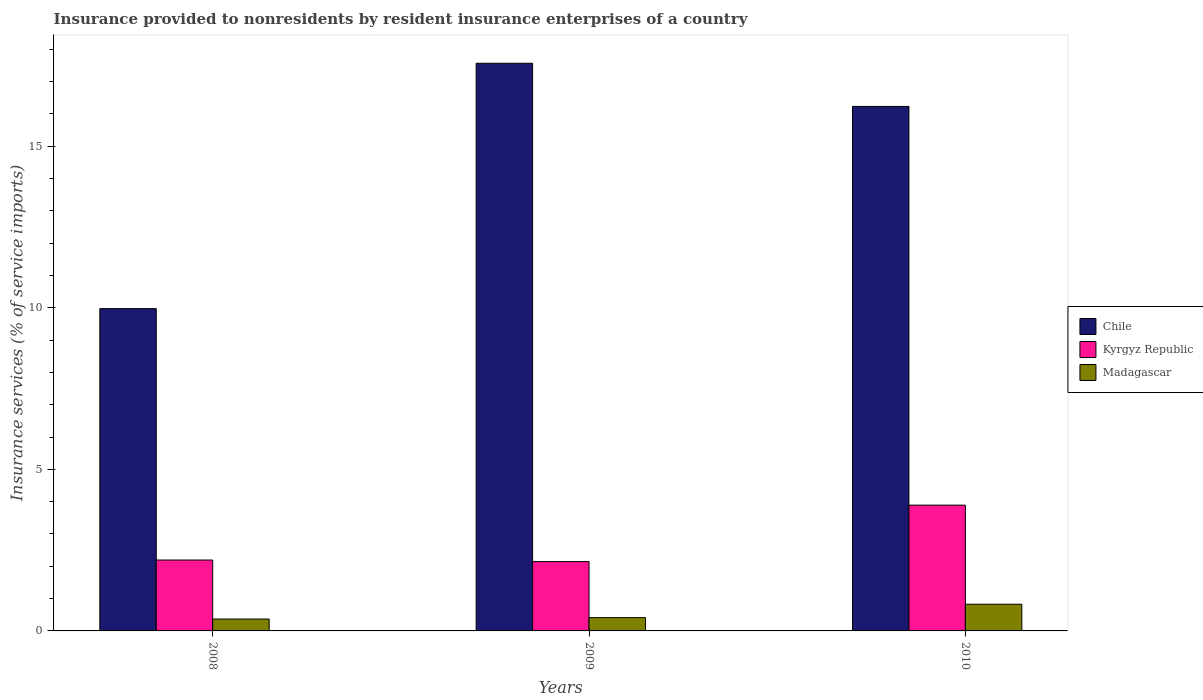How many groups of bars are there?
Provide a short and direct response. 3. Are the number of bars on each tick of the X-axis equal?
Provide a succinct answer. Yes. How many bars are there on the 3rd tick from the right?
Your response must be concise. 3. What is the insurance provided to nonresidents in Madagascar in 2010?
Ensure brevity in your answer.  0.83. Across all years, what is the maximum insurance provided to nonresidents in Kyrgyz Republic?
Your answer should be compact. 3.89. Across all years, what is the minimum insurance provided to nonresidents in Kyrgyz Republic?
Your answer should be very brief. 2.15. In which year was the insurance provided to nonresidents in Kyrgyz Republic minimum?
Offer a terse response. 2009. What is the total insurance provided to nonresidents in Chile in the graph?
Give a very brief answer. 43.78. What is the difference between the insurance provided to nonresidents in Kyrgyz Republic in 2009 and that in 2010?
Make the answer very short. -1.75. What is the difference between the insurance provided to nonresidents in Madagascar in 2008 and the insurance provided to nonresidents in Chile in 2010?
Keep it short and to the point. -15.87. What is the average insurance provided to nonresidents in Chile per year?
Keep it short and to the point. 14.59. In the year 2010, what is the difference between the insurance provided to nonresidents in Kyrgyz Republic and insurance provided to nonresidents in Madagascar?
Offer a very short reply. 3.07. In how many years, is the insurance provided to nonresidents in Madagascar greater than 16 %?
Offer a very short reply. 0. What is the ratio of the insurance provided to nonresidents in Madagascar in 2008 to that in 2009?
Your answer should be compact. 0.89. Is the difference between the insurance provided to nonresidents in Kyrgyz Republic in 2008 and 2010 greater than the difference between the insurance provided to nonresidents in Madagascar in 2008 and 2010?
Offer a terse response. No. What is the difference between the highest and the second highest insurance provided to nonresidents in Kyrgyz Republic?
Offer a terse response. 1.7. What is the difference between the highest and the lowest insurance provided to nonresidents in Madagascar?
Provide a short and direct response. 0.46. In how many years, is the insurance provided to nonresidents in Chile greater than the average insurance provided to nonresidents in Chile taken over all years?
Give a very brief answer. 2. Is the sum of the insurance provided to nonresidents in Kyrgyz Republic in 2009 and 2010 greater than the maximum insurance provided to nonresidents in Chile across all years?
Offer a terse response. No. What does the 2nd bar from the left in 2010 represents?
Give a very brief answer. Kyrgyz Republic. What does the 3rd bar from the right in 2008 represents?
Keep it short and to the point. Chile. Is it the case that in every year, the sum of the insurance provided to nonresidents in Kyrgyz Republic and insurance provided to nonresidents in Chile is greater than the insurance provided to nonresidents in Madagascar?
Provide a succinct answer. Yes. Are all the bars in the graph horizontal?
Provide a short and direct response. No. How many years are there in the graph?
Provide a succinct answer. 3. What is the difference between two consecutive major ticks on the Y-axis?
Provide a succinct answer. 5. Where does the legend appear in the graph?
Your response must be concise. Center right. What is the title of the graph?
Keep it short and to the point. Insurance provided to nonresidents by resident insurance enterprises of a country. What is the label or title of the Y-axis?
Your answer should be very brief. Insurance services (% of service imports). What is the Insurance services (% of service imports) of Chile in 2008?
Keep it short and to the point. 9.98. What is the Insurance services (% of service imports) of Kyrgyz Republic in 2008?
Ensure brevity in your answer.  2.19. What is the Insurance services (% of service imports) in Madagascar in 2008?
Make the answer very short. 0.37. What is the Insurance services (% of service imports) of Chile in 2009?
Keep it short and to the point. 17.57. What is the Insurance services (% of service imports) of Kyrgyz Republic in 2009?
Offer a very short reply. 2.15. What is the Insurance services (% of service imports) of Madagascar in 2009?
Keep it short and to the point. 0.41. What is the Insurance services (% of service imports) of Chile in 2010?
Provide a succinct answer. 16.23. What is the Insurance services (% of service imports) in Kyrgyz Republic in 2010?
Make the answer very short. 3.89. What is the Insurance services (% of service imports) of Madagascar in 2010?
Make the answer very short. 0.83. Across all years, what is the maximum Insurance services (% of service imports) of Chile?
Your answer should be compact. 17.57. Across all years, what is the maximum Insurance services (% of service imports) of Kyrgyz Republic?
Offer a very short reply. 3.89. Across all years, what is the maximum Insurance services (% of service imports) of Madagascar?
Your response must be concise. 0.83. Across all years, what is the minimum Insurance services (% of service imports) of Chile?
Ensure brevity in your answer.  9.98. Across all years, what is the minimum Insurance services (% of service imports) in Kyrgyz Republic?
Provide a short and direct response. 2.15. Across all years, what is the minimum Insurance services (% of service imports) in Madagascar?
Give a very brief answer. 0.37. What is the total Insurance services (% of service imports) of Chile in the graph?
Offer a very short reply. 43.78. What is the total Insurance services (% of service imports) in Kyrgyz Republic in the graph?
Give a very brief answer. 8.23. What is the total Insurance services (% of service imports) in Madagascar in the graph?
Your answer should be compact. 1.61. What is the difference between the Insurance services (% of service imports) in Chile in 2008 and that in 2009?
Your response must be concise. -7.59. What is the difference between the Insurance services (% of service imports) in Kyrgyz Republic in 2008 and that in 2009?
Your answer should be very brief. 0.05. What is the difference between the Insurance services (% of service imports) of Madagascar in 2008 and that in 2009?
Keep it short and to the point. -0.04. What is the difference between the Insurance services (% of service imports) of Chile in 2008 and that in 2010?
Your answer should be compact. -6.26. What is the difference between the Insurance services (% of service imports) of Kyrgyz Republic in 2008 and that in 2010?
Offer a very short reply. -1.7. What is the difference between the Insurance services (% of service imports) of Madagascar in 2008 and that in 2010?
Your response must be concise. -0.46. What is the difference between the Insurance services (% of service imports) of Chile in 2009 and that in 2010?
Keep it short and to the point. 1.34. What is the difference between the Insurance services (% of service imports) of Kyrgyz Republic in 2009 and that in 2010?
Your response must be concise. -1.75. What is the difference between the Insurance services (% of service imports) of Madagascar in 2009 and that in 2010?
Make the answer very short. -0.41. What is the difference between the Insurance services (% of service imports) of Chile in 2008 and the Insurance services (% of service imports) of Kyrgyz Republic in 2009?
Provide a succinct answer. 7.83. What is the difference between the Insurance services (% of service imports) of Chile in 2008 and the Insurance services (% of service imports) of Madagascar in 2009?
Your response must be concise. 9.56. What is the difference between the Insurance services (% of service imports) of Kyrgyz Republic in 2008 and the Insurance services (% of service imports) of Madagascar in 2009?
Provide a succinct answer. 1.78. What is the difference between the Insurance services (% of service imports) in Chile in 2008 and the Insurance services (% of service imports) in Kyrgyz Republic in 2010?
Your answer should be compact. 6.08. What is the difference between the Insurance services (% of service imports) in Chile in 2008 and the Insurance services (% of service imports) in Madagascar in 2010?
Keep it short and to the point. 9.15. What is the difference between the Insurance services (% of service imports) in Kyrgyz Republic in 2008 and the Insurance services (% of service imports) in Madagascar in 2010?
Provide a short and direct response. 1.37. What is the difference between the Insurance services (% of service imports) of Chile in 2009 and the Insurance services (% of service imports) of Kyrgyz Republic in 2010?
Keep it short and to the point. 13.68. What is the difference between the Insurance services (% of service imports) in Chile in 2009 and the Insurance services (% of service imports) in Madagascar in 2010?
Your answer should be compact. 16.74. What is the difference between the Insurance services (% of service imports) of Kyrgyz Republic in 2009 and the Insurance services (% of service imports) of Madagascar in 2010?
Your answer should be compact. 1.32. What is the average Insurance services (% of service imports) of Chile per year?
Keep it short and to the point. 14.59. What is the average Insurance services (% of service imports) in Kyrgyz Republic per year?
Ensure brevity in your answer.  2.74. What is the average Insurance services (% of service imports) of Madagascar per year?
Offer a very short reply. 0.54. In the year 2008, what is the difference between the Insurance services (% of service imports) of Chile and Insurance services (% of service imports) of Kyrgyz Republic?
Offer a terse response. 7.78. In the year 2008, what is the difference between the Insurance services (% of service imports) in Chile and Insurance services (% of service imports) in Madagascar?
Provide a succinct answer. 9.61. In the year 2008, what is the difference between the Insurance services (% of service imports) of Kyrgyz Republic and Insurance services (% of service imports) of Madagascar?
Make the answer very short. 1.83. In the year 2009, what is the difference between the Insurance services (% of service imports) in Chile and Insurance services (% of service imports) in Kyrgyz Republic?
Your response must be concise. 15.42. In the year 2009, what is the difference between the Insurance services (% of service imports) in Chile and Insurance services (% of service imports) in Madagascar?
Give a very brief answer. 17.16. In the year 2009, what is the difference between the Insurance services (% of service imports) of Kyrgyz Republic and Insurance services (% of service imports) of Madagascar?
Your response must be concise. 1.74. In the year 2010, what is the difference between the Insurance services (% of service imports) in Chile and Insurance services (% of service imports) in Kyrgyz Republic?
Offer a very short reply. 12.34. In the year 2010, what is the difference between the Insurance services (% of service imports) in Chile and Insurance services (% of service imports) in Madagascar?
Your answer should be very brief. 15.41. In the year 2010, what is the difference between the Insurance services (% of service imports) of Kyrgyz Republic and Insurance services (% of service imports) of Madagascar?
Ensure brevity in your answer.  3.07. What is the ratio of the Insurance services (% of service imports) of Chile in 2008 to that in 2009?
Your response must be concise. 0.57. What is the ratio of the Insurance services (% of service imports) of Kyrgyz Republic in 2008 to that in 2009?
Make the answer very short. 1.02. What is the ratio of the Insurance services (% of service imports) of Madagascar in 2008 to that in 2009?
Provide a succinct answer. 0.89. What is the ratio of the Insurance services (% of service imports) in Chile in 2008 to that in 2010?
Your answer should be compact. 0.61. What is the ratio of the Insurance services (% of service imports) of Kyrgyz Republic in 2008 to that in 2010?
Offer a very short reply. 0.56. What is the ratio of the Insurance services (% of service imports) in Madagascar in 2008 to that in 2010?
Offer a terse response. 0.45. What is the ratio of the Insurance services (% of service imports) in Chile in 2009 to that in 2010?
Your response must be concise. 1.08. What is the ratio of the Insurance services (% of service imports) in Kyrgyz Republic in 2009 to that in 2010?
Offer a very short reply. 0.55. What is the ratio of the Insurance services (% of service imports) of Madagascar in 2009 to that in 2010?
Your response must be concise. 0.5. What is the difference between the highest and the second highest Insurance services (% of service imports) of Chile?
Provide a succinct answer. 1.34. What is the difference between the highest and the second highest Insurance services (% of service imports) in Kyrgyz Republic?
Offer a very short reply. 1.7. What is the difference between the highest and the second highest Insurance services (% of service imports) of Madagascar?
Ensure brevity in your answer.  0.41. What is the difference between the highest and the lowest Insurance services (% of service imports) in Chile?
Your response must be concise. 7.59. What is the difference between the highest and the lowest Insurance services (% of service imports) of Kyrgyz Republic?
Your answer should be compact. 1.75. What is the difference between the highest and the lowest Insurance services (% of service imports) in Madagascar?
Offer a terse response. 0.46. 